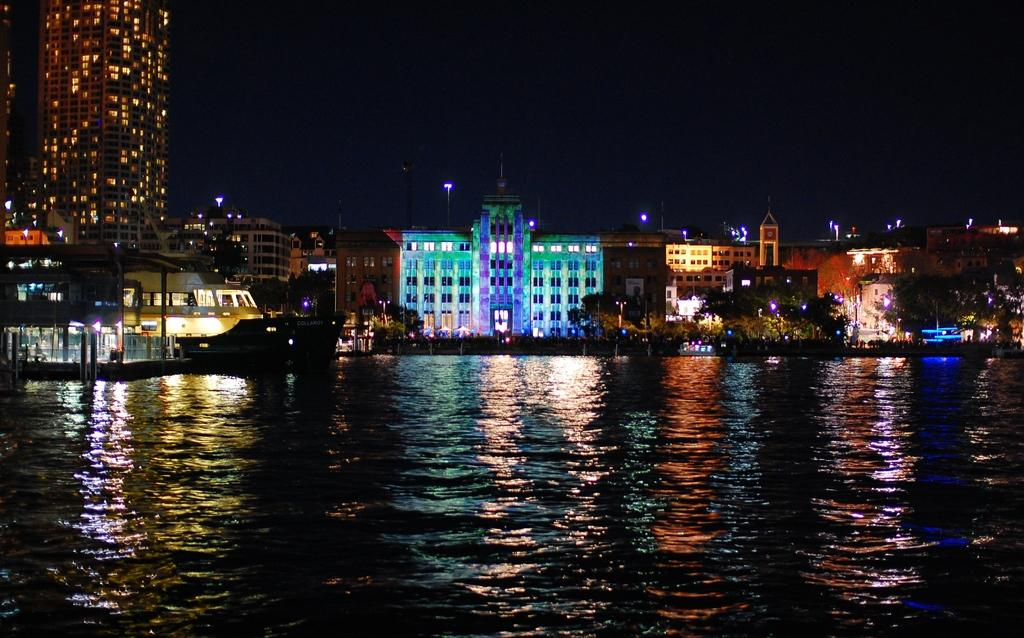What type of structures can be seen in the image? There are buildings in the image. What other natural elements are present in the image? There are trees in the image. Are there any artificial light sources visible in the image? Yes, there are lights in the image. What can be seen at the bottom of the image? There is water visible at the bottom of the image. What is located on the surface of the water on the left side of the image? There is a boat on the surface of the water on the left side of the image. How many yams are being transported by the truck in the image? There is no truck present in the image, and therefore no yams being transported. What type of division is depicted in the image? The image does not depict any divisions; it features buildings, trees, lights, water, and a boat. 